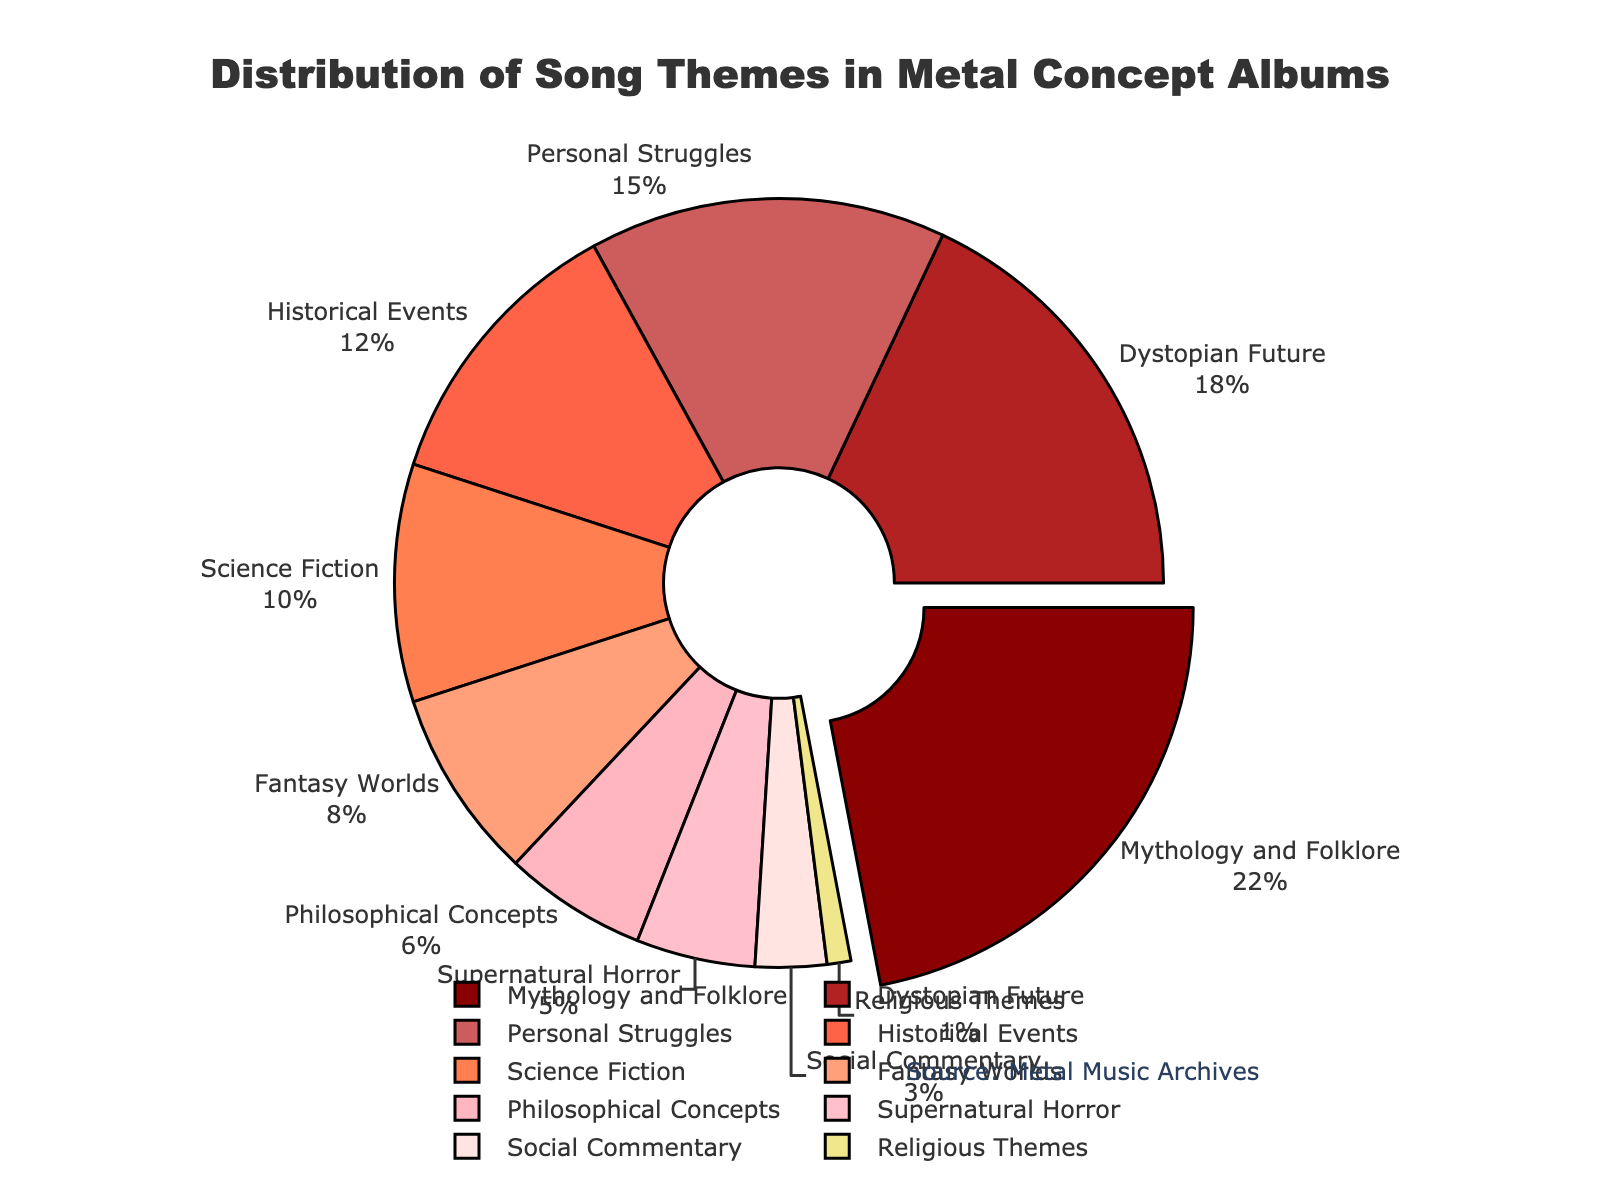Which song theme has the highest percentage in the chart? The chart shows various song themes with their corresponding percentages. By looking at the values, 'Mythology and Folklore' has the highest percentage.
Answer: Mythology and Folklore What percentage of themes are related to 'Historical Events' and 'Science Fiction' combined? To find the combined percentage, add the values for 'Historical Events' and 'Science Fiction'. 'Historical Events' is 12% and 'Science Fiction' is 10%. Therefore, 12% + 10% = 22%.
Answer: 22% How does the percentage of 'Personal Struggles' compare to the percentage of 'Supernatural Horror'? Look at the percentages for 'Personal Struggles' and 'Supernatural Horror'. 'Personal Struggles' is 15%, while 'Supernatural Horror' is 5%. 'Personal Struggles' has a higher percentage than 'Supernatural Horror'.
Answer: Personal Struggles has a higher percentage What is the difference in percentage between 'Social Commentary' and 'Religious Themes'? Subtract the percentage of 'Religious Themes' from 'Social Commentary'. 'Social Commentary' is 3%, and 'Religious Themes' is 1%. So the difference is 3% - 1% = 2%.
Answer: 2% Which theme is represented by the second largest portion of the chart? By observing the chart, after 'Mythology and Folklore', the next largest portion corresponds to 'Dystopian Future' with 18%.
Answer: Dystopian Future What is the average percentage of the themes 'Philosophical Concepts', 'Supernatural Horror', and 'Social Commentary'? Add the percentages for 'Philosophical Concepts' (6%), 'Supernatural Horror' (5%), and 'Social Commentary' (3%), then divide by the number of themes (3). (6% + 5% + 3%) / 3 = 14% / 3 ≈ 4.67%.
Answer: 4.67% What is the total percentage of themes related to imaginary worlds ('Fantasy Worlds' and 'Science Fiction')? Add the percentages for 'Fantasy Worlds' and 'Science Fiction'. 'Fantasy Worlds' is 8%, and 'Science Fiction' is 10%. So, 8% + 10% = 18%.
Answer: 18% Between 'Historical Events' and 'Personal Struggles', which theme has a smaller percentage, and by how much? 'Historical Events' has a percentage of 12% and 'Personal Struggles' has 15%. The difference is 15% - 12% = 3%, and 'Historical Events' has the smaller percentage.
Answer: Historical Events by 3% What is the least represented song theme in the chart? The least represented song theme is the one with the smallest percentage. 'Religious Themes' has the smallest percentage at 1%.
Answer: Religious Themes 